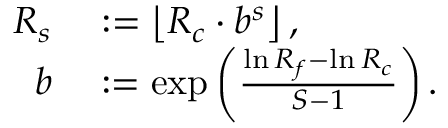<formula> <loc_0><loc_0><loc_500><loc_500>\begin{array} { r l } { R _ { s } } & \colon = \left \lfloor R _ { c } \cdot b ^ { s } \right \rfloor , } \\ { b } & \colon = \exp \left ( \frac { \ln R _ { f } - \ln R _ { c } } { S - 1 } \right ) . } \end{array}</formula> 